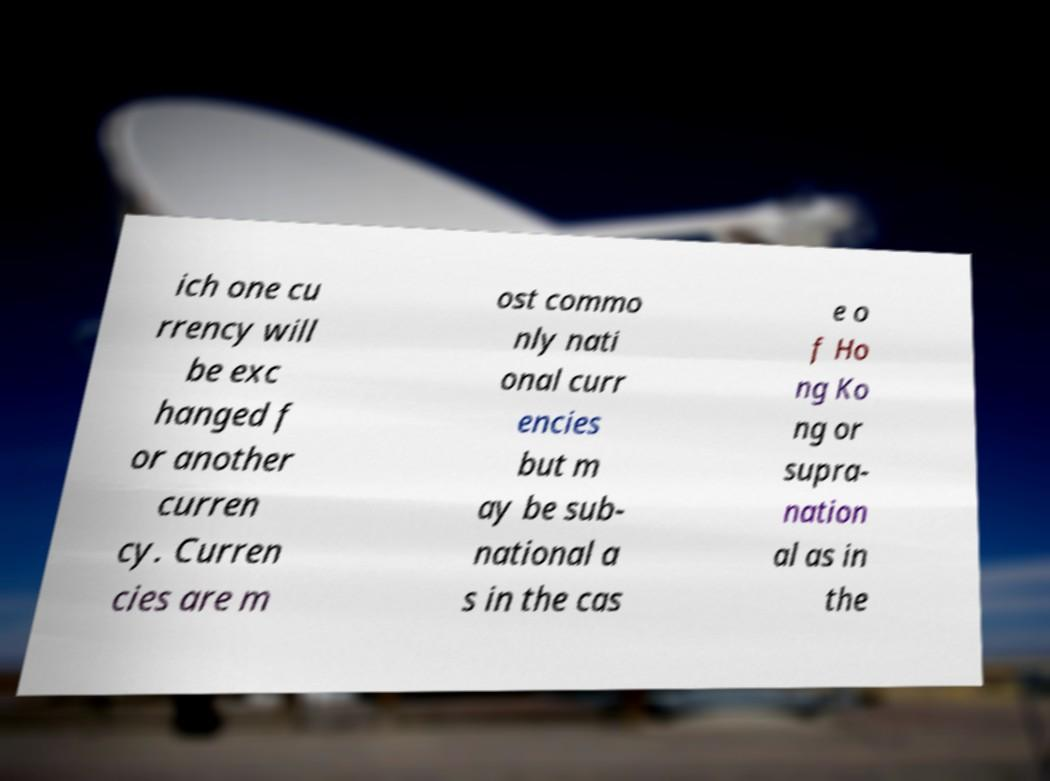Please identify and transcribe the text found in this image. ich one cu rrency will be exc hanged f or another curren cy. Curren cies are m ost commo nly nati onal curr encies but m ay be sub- national a s in the cas e o f Ho ng Ko ng or supra- nation al as in the 